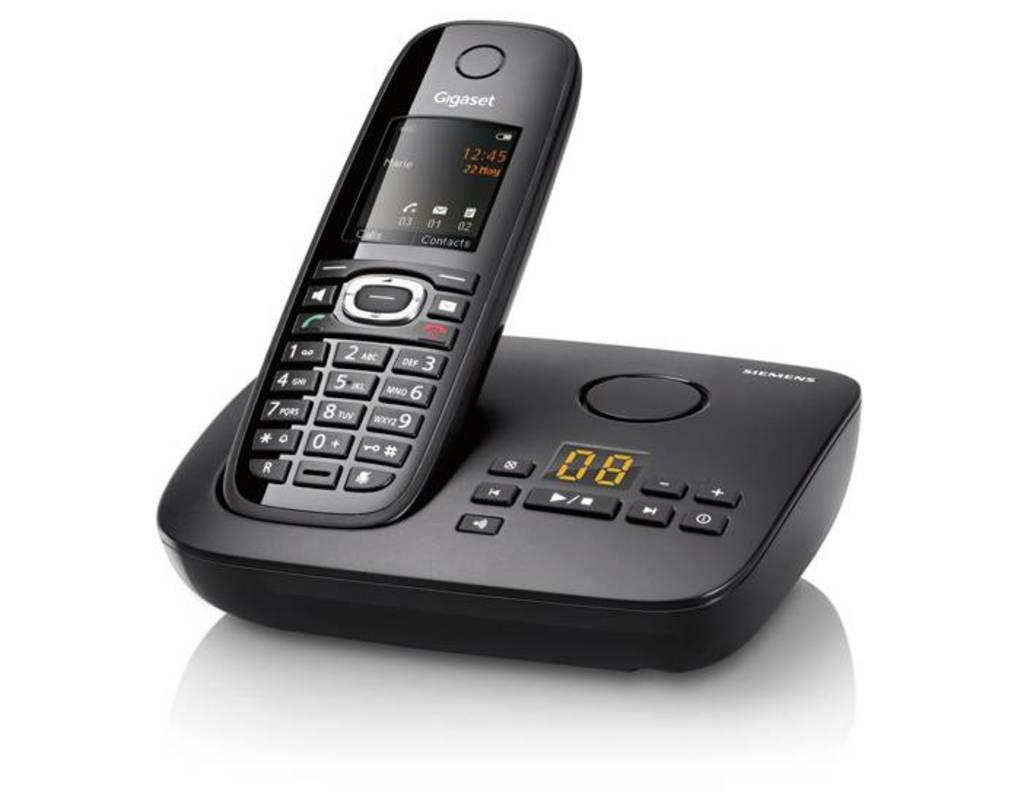<image>
Summarize the visual content of the image. The phone shown in the image is made by siemens. 